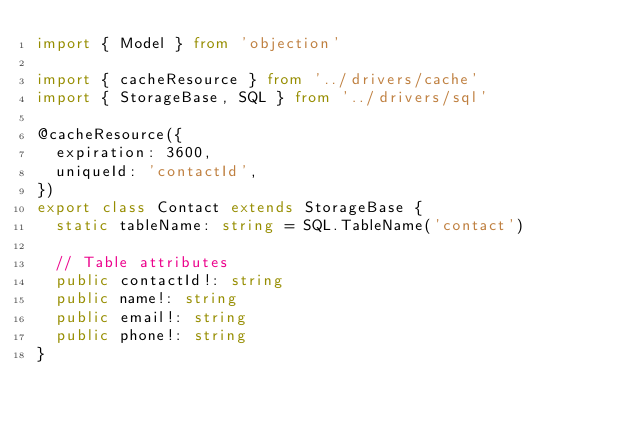<code> <loc_0><loc_0><loc_500><loc_500><_TypeScript_>import { Model } from 'objection'

import { cacheResource } from '../drivers/cache'
import { StorageBase, SQL } from '../drivers/sql'

@cacheResource({
  expiration: 3600,
  uniqueId: 'contactId',
})
export class Contact extends StorageBase {
  static tableName: string = SQL.TableName('contact')

  // Table attributes
  public contactId!: string
  public name!: string
  public email!: string
  public phone!: string
}
</code> 